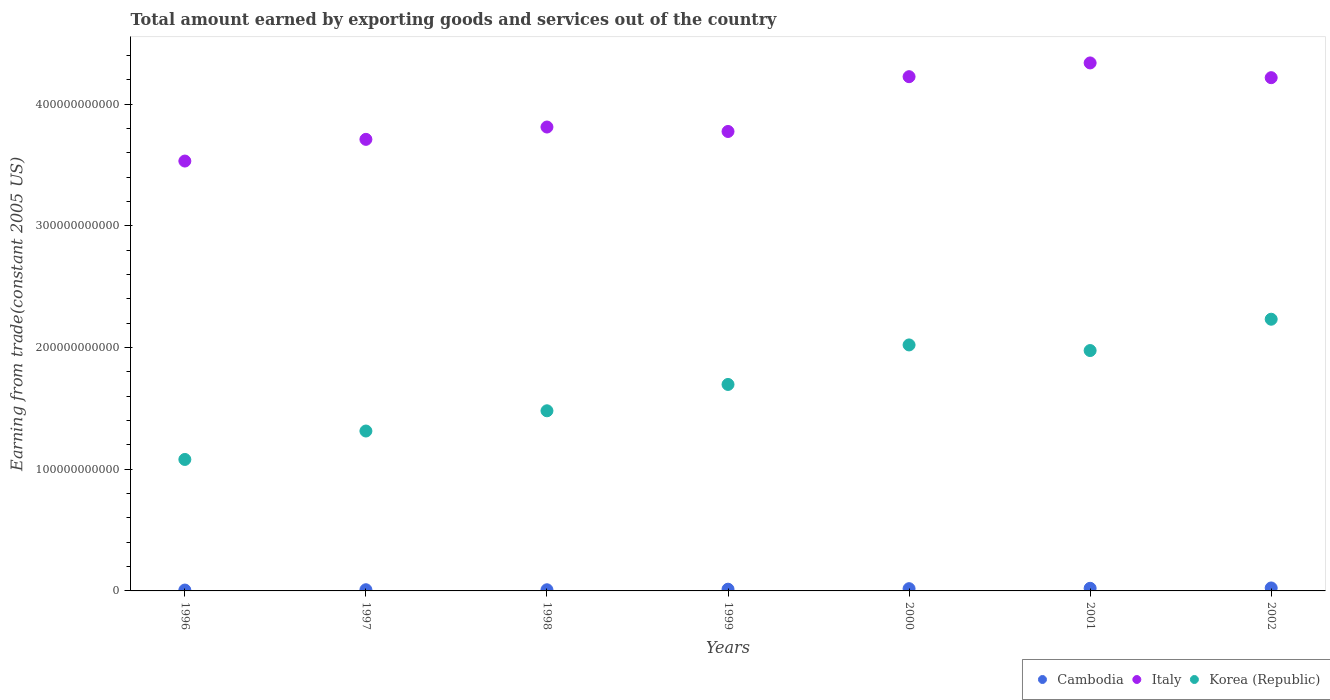Is the number of dotlines equal to the number of legend labels?
Offer a very short reply. Yes. What is the total amount earned by exporting goods and services in Cambodia in 1998?
Make the answer very short. 9.47e+08. Across all years, what is the maximum total amount earned by exporting goods and services in Italy?
Offer a terse response. 4.34e+11. Across all years, what is the minimum total amount earned by exporting goods and services in Korea (Republic)?
Offer a very short reply. 1.08e+11. What is the total total amount earned by exporting goods and services in Korea (Republic) in the graph?
Keep it short and to the point. 1.18e+12. What is the difference between the total amount earned by exporting goods and services in Italy in 1996 and that in 2002?
Your answer should be compact. -6.85e+1. What is the difference between the total amount earned by exporting goods and services in Italy in 1999 and the total amount earned by exporting goods and services in Korea (Republic) in 2001?
Provide a short and direct response. 1.80e+11. What is the average total amount earned by exporting goods and services in Italy per year?
Your answer should be very brief. 3.94e+11. In the year 1999, what is the difference between the total amount earned by exporting goods and services in Korea (Republic) and total amount earned by exporting goods and services in Italy?
Provide a short and direct response. -2.08e+11. In how many years, is the total amount earned by exporting goods and services in Cambodia greater than 280000000000 US$?
Provide a short and direct response. 0. What is the ratio of the total amount earned by exporting goods and services in Italy in 1996 to that in 2002?
Your response must be concise. 0.84. Is the total amount earned by exporting goods and services in Cambodia in 1996 less than that in 2001?
Give a very brief answer. Yes. What is the difference between the highest and the second highest total amount earned by exporting goods and services in Italy?
Keep it short and to the point. 1.13e+1. What is the difference between the highest and the lowest total amount earned by exporting goods and services in Italy?
Provide a succinct answer. 8.06e+1. In how many years, is the total amount earned by exporting goods and services in Cambodia greater than the average total amount earned by exporting goods and services in Cambodia taken over all years?
Keep it short and to the point. 3. Is the sum of the total amount earned by exporting goods and services in Italy in 1996 and 2002 greater than the maximum total amount earned by exporting goods and services in Cambodia across all years?
Your answer should be very brief. Yes. Is the total amount earned by exporting goods and services in Italy strictly greater than the total amount earned by exporting goods and services in Cambodia over the years?
Keep it short and to the point. Yes. How many years are there in the graph?
Your response must be concise. 7. What is the difference between two consecutive major ticks on the Y-axis?
Your response must be concise. 1.00e+11. Does the graph contain grids?
Provide a succinct answer. No. Where does the legend appear in the graph?
Your answer should be very brief. Bottom right. What is the title of the graph?
Your answer should be very brief. Total amount earned by exporting goods and services out of the country. What is the label or title of the Y-axis?
Your answer should be very brief. Earning from trade(constant 2005 US). What is the Earning from trade(constant 2005 US) of Cambodia in 1996?
Offer a very short reply. 7.17e+08. What is the Earning from trade(constant 2005 US) in Italy in 1996?
Keep it short and to the point. 3.53e+11. What is the Earning from trade(constant 2005 US) in Korea (Republic) in 1996?
Ensure brevity in your answer.  1.08e+11. What is the Earning from trade(constant 2005 US) of Cambodia in 1997?
Provide a short and direct response. 9.76e+08. What is the Earning from trade(constant 2005 US) in Italy in 1997?
Your answer should be very brief. 3.71e+11. What is the Earning from trade(constant 2005 US) of Korea (Republic) in 1997?
Give a very brief answer. 1.31e+11. What is the Earning from trade(constant 2005 US) in Cambodia in 1998?
Your response must be concise. 9.47e+08. What is the Earning from trade(constant 2005 US) of Italy in 1998?
Offer a very short reply. 3.81e+11. What is the Earning from trade(constant 2005 US) of Korea (Republic) in 1998?
Offer a terse response. 1.48e+11. What is the Earning from trade(constant 2005 US) in Cambodia in 1999?
Keep it short and to the point. 1.42e+09. What is the Earning from trade(constant 2005 US) in Italy in 1999?
Your response must be concise. 3.77e+11. What is the Earning from trade(constant 2005 US) in Korea (Republic) in 1999?
Ensure brevity in your answer.  1.70e+11. What is the Earning from trade(constant 2005 US) of Cambodia in 2000?
Ensure brevity in your answer.  1.85e+09. What is the Earning from trade(constant 2005 US) in Italy in 2000?
Keep it short and to the point. 4.22e+11. What is the Earning from trade(constant 2005 US) in Korea (Republic) in 2000?
Make the answer very short. 2.02e+11. What is the Earning from trade(constant 2005 US) in Cambodia in 2001?
Keep it short and to the point. 2.15e+09. What is the Earning from trade(constant 2005 US) of Italy in 2001?
Give a very brief answer. 4.34e+11. What is the Earning from trade(constant 2005 US) of Korea (Republic) in 2001?
Provide a short and direct response. 1.97e+11. What is the Earning from trade(constant 2005 US) of Cambodia in 2002?
Provide a short and direct response. 2.44e+09. What is the Earning from trade(constant 2005 US) of Italy in 2002?
Offer a very short reply. 4.22e+11. What is the Earning from trade(constant 2005 US) of Korea (Republic) in 2002?
Keep it short and to the point. 2.23e+11. Across all years, what is the maximum Earning from trade(constant 2005 US) in Cambodia?
Make the answer very short. 2.44e+09. Across all years, what is the maximum Earning from trade(constant 2005 US) of Italy?
Provide a succinct answer. 4.34e+11. Across all years, what is the maximum Earning from trade(constant 2005 US) in Korea (Republic)?
Your response must be concise. 2.23e+11. Across all years, what is the minimum Earning from trade(constant 2005 US) of Cambodia?
Keep it short and to the point. 7.17e+08. Across all years, what is the minimum Earning from trade(constant 2005 US) of Italy?
Offer a terse response. 3.53e+11. Across all years, what is the minimum Earning from trade(constant 2005 US) in Korea (Republic)?
Your response must be concise. 1.08e+11. What is the total Earning from trade(constant 2005 US) of Cambodia in the graph?
Keep it short and to the point. 1.05e+1. What is the total Earning from trade(constant 2005 US) in Italy in the graph?
Ensure brevity in your answer.  2.76e+12. What is the total Earning from trade(constant 2005 US) in Korea (Republic) in the graph?
Your response must be concise. 1.18e+12. What is the difference between the Earning from trade(constant 2005 US) of Cambodia in 1996 and that in 1997?
Give a very brief answer. -2.59e+08. What is the difference between the Earning from trade(constant 2005 US) in Italy in 1996 and that in 1997?
Your response must be concise. -1.78e+1. What is the difference between the Earning from trade(constant 2005 US) of Korea (Republic) in 1996 and that in 1997?
Provide a succinct answer. -2.34e+1. What is the difference between the Earning from trade(constant 2005 US) of Cambodia in 1996 and that in 1998?
Give a very brief answer. -2.30e+08. What is the difference between the Earning from trade(constant 2005 US) of Italy in 1996 and that in 1998?
Offer a terse response. -2.79e+1. What is the difference between the Earning from trade(constant 2005 US) in Korea (Republic) in 1996 and that in 1998?
Offer a terse response. -4.00e+1. What is the difference between the Earning from trade(constant 2005 US) in Cambodia in 1996 and that in 1999?
Provide a short and direct response. -7.00e+08. What is the difference between the Earning from trade(constant 2005 US) of Italy in 1996 and that in 1999?
Offer a terse response. -2.43e+1. What is the difference between the Earning from trade(constant 2005 US) of Korea (Republic) in 1996 and that in 1999?
Keep it short and to the point. -6.16e+1. What is the difference between the Earning from trade(constant 2005 US) of Cambodia in 1996 and that in 2000?
Give a very brief answer. -1.13e+09. What is the difference between the Earning from trade(constant 2005 US) in Italy in 1996 and that in 2000?
Offer a terse response. -6.93e+1. What is the difference between the Earning from trade(constant 2005 US) in Korea (Republic) in 1996 and that in 2000?
Keep it short and to the point. -9.41e+1. What is the difference between the Earning from trade(constant 2005 US) in Cambodia in 1996 and that in 2001?
Offer a terse response. -1.44e+09. What is the difference between the Earning from trade(constant 2005 US) in Italy in 1996 and that in 2001?
Give a very brief answer. -8.06e+1. What is the difference between the Earning from trade(constant 2005 US) of Korea (Republic) in 1996 and that in 2001?
Ensure brevity in your answer.  -8.95e+1. What is the difference between the Earning from trade(constant 2005 US) of Cambodia in 1996 and that in 2002?
Your response must be concise. -1.72e+09. What is the difference between the Earning from trade(constant 2005 US) of Italy in 1996 and that in 2002?
Ensure brevity in your answer.  -6.85e+1. What is the difference between the Earning from trade(constant 2005 US) of Korea (Republic) in 1996 and that in 2002?
Keep it short and to the point. -1.15e+11. What is the difference between the Earning from trade(constant 2005 US) in Cambodia in 1997 and that in 1998?
Keep it short and to the point. 2.89e+07. What is the difference between the Earning from trade(constant 2005 US) of Italy in 1997 and that in 1998?
Your answer should be compact. -1.01e+1. What is the difference between the Earning from trade(constant 2005 US) in Korea (Republic) in 1997 and that in 1998?
Offer a terse response. -1.66e+1. What is the difference between the Earning from trade(constant 2005 US) in Cambodia in 1997 and that in 1999?
Make the answer very short. -4.41e+08. What is the difference between the Earning from trade(constant 2005 US) of Italy in 1997 and that in 1999?
Ensure brevity in your answer.  -6.47e+09. What is the difference between the Earning from trade(constant 2005 US) of Korea (Republic) in 1997 and that in 1999?
Offer a terse response. -3.83e+1. What is the difference between the Earning from trade(constant 2005 US) of Cambodia in 1997 and that in 2000?
Your answer should be very brief. -8.70e+08. What is the difference between the Earning from trade(constant 2005 US) in Italy in 1997 and that in 2000?
Your answer should be compact. -5.15e+1. What is the difference between the Earning from trade(constant 2005 US) of Korea (Republic) in 1997 and that in 2000?
Your answer should be compact. -7.07e+1. What is the difference between the Earning from trade(constant 2005 US) in Cambodia in 1997 and that in 2001?
Ensure brevity in your answer.  -1.18e+09. What is the difference between the Earning from trade(constant 2005 US) of Italy in 1997 and that in 2001?
Offer a terse response. -6.28e+1. What is the difference between the Earning from trade(constant 2005 US) of Korea (Republic) in 1997 and that in 2001?
Offer a very short reply. -6.61e+1. What is the difference between the Earning from trade(constant 2005 US) of Cambodia in 1997 and that in 2002?
Offer a very short reply. -1.46e+09. What is the difference between the Earning from trade(constant 2005 US) of Italy in 1997 and that in 2002?
Offer a very short reply. -5.07e+1. What is the difference between the Earning from trade(constant 2005 US) of Korea (Republic) in 1997 and that in 2002?
Provide a short and direct response. -9.18e+1. What is the difference between the Earning from trade(constant 2005 US) of Cambodia in 1998 and that in 1999?
Offer a terse response. -4.70e+08. What is the difference between the Earning from trade(constant 2005 US) in Italy in 1998 and that in 1999?
Offer a terse response. 3.66e+09. What is the difference between the Earning from trade(constant 2005 US) of Korea (Republic) in 1998 and that in 1999?
Make the answer very short. -2.16e+1. What is the difference between the Earning from trade(constant 2005 US) of Cambodia in 1998 and that in 2000?
Provide a succinct answer. -8.99e+08. What is the difference between the Earning from trade(constant 2005 US) in Italy in 1998 and that in 2000?
Ensure brevity in your answer.  -4.14e+1. What is the difference between the Earning from trade(constant 2005 US) of Korea (Republic) in 1998 and that in 2000?
Your answer should be very brief. -5.41e+1. What is the difference between the Earning from trade(constant 2005 US) of Cambodia in 1998 and that in 2001?
Make the answer very short. -1.21e+09. What is the difference between the Earning from trade(constant 2005 US) of Italy in 1998 and that in 2001?
Make the answer very short. -5.27e+1. What is the difference between the Earning from trade(constant 2005 US) in Korea (Republic) in 1998 and that in 2001?
Ensure brevity in your answer.  -4.95e+1. What is the difference between the Earning from trade(constant 2005 US) in Cambodia in 1998 and that in 2002?
Ensure brevity in your answer.  -1.49e+09. What is the difference between the Earning from trade(constant 2005 US) in Italy in 1998 and that in 2002?
Give a very brief answer. -4.05e+1. What is the difference between the Earning from trade(constant 2005 US) of Korea (Republic) in 1998 and that in 2002?
Keep it short and to the point. -7.52e+1. What is the difference between the Earning from trade(constant 2005 US) in Cambodia in 1999 and that in 2000?
Your response must be concise. -4.29e+08. What is the difference between the Earning from trade(constant 2005 US) in Italy in 1999 and that in 2000?
Your answer should be very brief. -4.50e+1. What is the difference between the Earning from trade(constant 2005 US) in Korea (Republic) in 1999 and that in 2000?
Your answer should be very brief. -3.25e+1. What is the difference between the Earning from trade(constant 2005 US) in Cambodia in 1999 and that in 2001?
Give a very brief answer. -7.37e+08. What is the difference between the Earning from trade(constant 2005 US) in Italy in 1999 and that in 2001?
Your response must be concise. -5.63e+1. What is the difference between the Earning from trade(constant 2005 US) in Korea (Republic) in 1999 and that in 2001?
Provide a short and direct response. -2.79e+1. What is the difference between the Earning from trade(constant 2005 US) of Cambodia in 1999 and that in 2002?
Your answer should be very brief. -1.02e+09. What is the difference between the Earning from trade(constant 2005 US) in Italy in 1999 and that in 2002?
Offer a very short reply. -4.42e+1. What is the difference between the Earning from trade(constant 2005 US) of Korea (Republic) in 1999 and that in 2002?
Ensure brevity in your answer.  -5.36e+1. What is the difference between the Earning from trade(constant 2005 US) of Cambodia in 2000 and that in 2001?
Make the answer very short. -3.08e+08. What is the difference between the Earning from trade(constant 2005 US) in Italy in 2000 and that in 2001?
Provide a succinct answer. -1.13e+1. What is the difference between the Earning from trade(constant 2005 US) in Korea (Republic) in 2000 and that in 2001?
Your answer should be very brief. 4.62e+09. What is the difference between the Earning from trade(constant 2005 US) in Cambodia in 2000 and that in 2002?
Make the answer very short. -5.89e+08. What is the difference between the Earning from trade(constant 2005 US) of Italy in 2000 and that in 2002?
Offer a terse response. 8.18e+08. What is the difference between the Earning from trade(constant 2005 US) in Korea (Republic) in 2000 and that in 2002?
Your answer should be very brief. -2.11e+1. What is the difference between the Earning from trade(constant 2005 US) of Cambodia in 2001 and that in 2002?
Provide a short and direct response. -2.81e+08. What is the difference between the Earning from trade(constant 2005 US) in Italy in 2001 and that in 2002?
Provide a short and direct response. 1.21e+1. What is the difference between the Earning from trade(constant 2005 US) in Korea (Republic) in 2001 and that in 2002?
Offer a terse response. -2.57e+1. What is the difference between the Earning from trade(constant 2005 US) of Cambodia in 1996 and the Earning from trade(constant 2005 US) of Italy in 1997?
Give a very brief answer. -3.70e+11. What is the difference between the Earning from trade(constant 2005 US) in Cambodia in 1996 and the Earning from trade(constant 2005 US) in Korea (Republic) in 1997?
Your answer should be compact. -1.31e+11. What is the difference between the Earning from trade(constant 2005 US) in Italy in 1996 and the Earning from trade(constant 2005 US) in Korea (Republic) in 1997?
Your answer should be compact. 2.22e+11. What is the difference between the Earning from trade(constant 2005 US) of Cambodia in 1996 and the Earning from trade(constant 2005 US) of Italy in 1998?
Offer a terse response. -3.80e+11. What is the difference between the Earning from trade(constant 2005 US) in Cambodia in 1996 and the Earning from trade(constant 2005 US) in Korea (Republic) in 1998?
Your answer should be compact. -1.47e+11. What is the difference between the Earning from trade(constant 2005 US) in Italy in 1996 and the Earning from trade(constant 2005 US) in Korea (Republic) in 1998?
Ensure brevity in your answer.  2.05e+11. What is the difference between the Earning from trade(constant 2005 US) in Cambodia in 1996 and the Earning from trade(constant 2005 US) in Italy in 1999?
Keep it short and to the point. -3.77e+11. What is the difference between the Earning from trade(constant 2005 US) in Cambodia in 1996 and the Earning from trade(constant 2005 US) in Korea (Republic) in 1999?
Your answer should be very brief. -1.69e+11. What is the difference between the Earning from trade(constant 2005 US) of Italy in 1996 and the Earning from trade(constant 2005 US) of Korea (Republic) in 1999?
Your response must be concise. 1.84e+11. What is the difference between the Earning from trade(constant 2005 US) of Cambodia in 1996 and the Earning from trade(constant 2005 US) of Italy in 2000?
Keep it short and to the point. -4.22e+11. What is the difference between the Earning from trade(constant 2005 US) in Cambodia in 1996 and the Earning from trade(constant 2005 US) in Korea (Republic) in 2000?
Give a very brief answer. -2.01e+11. What is the difference between the Earning from trade(constant 2005 US) in Italy in 1996 and the Earning from trade(constant 2005 US) in Korea (Republic) in 2000?
Offer a very short reply. 1.51e+11. What is the difference between the Earning from trade(constant 2005 US) in Cambodia in 1996 and the Earning from trade(constant 2005 US) in Italy in 2001?
Offer a terse response. -4.33e+11. What is the difference between the Earning from trade(constant 2005 US) of Cambodia in 1996 and the Earning from trade(constant 2005 US) of Korea (Republic) in 2001?
Make the answer very short. -1.97e+11. What is the difference between the Earning from trade(constant 2005 US) of Italy in 1996 and the Earning from trade(constant 2005 US) of Korea (Republic) in 2001?
Make the answer very short. 1.56e+11. What is the difference between the Earning from trade(constant 2005 US) in Cambodia in 1996 and the Earning from trade(constant 2005 US) in Italy in 2002?
Keep it short and to the point. -4.21e+11. What is the difference between the Earning from trade(constant 2005 US) of Cambodia in 1996 and the Earning from trade(constant 2005 US) of Korea (Republic) in 2002?
Your answer should be very brief. -2.22e+11. What is the difference between the Earning from trade(constant 2005 US) of Italy in 1996 and the Earning from trade(constant 2005 US) of Korea (Republic) in 2002?
Your response must be concise. 1.30e+11. What is the difference between the Earning from trade(constant 2005 US) in Cambodia in 1997 and the Earning from trade(constant 2005 US) in Italy in 1998?
Provide a succinct answer. -3.80e+11. What is the difference between the Earning from trade(constant 2005 US) of Cambodia in 1997 and the Earning from trade(constant 2005 US) of Korea (Republic) in 1998?
Provide a succinct answer. -1.47e+11. What is the difference between the Earning from trade(constant 2005 US) in Italy in 1997 and the Earning from trade(constant 2005 US) in Korea (Republic) in 1998?
Your response must be concise. 2.23e+11. What is the difference between the Earning from trade(constant 2005 US) in Cambodia in 1997 and the Earning from trade(constant 2005 US) in Italy in 1999?
Your answer should be very brief. -3.76e+11. What is the difference between the Earning from trade(constant 2005 US) in Cambodia in 1997 and the Earning from trade(constant 2005 US) in Korea (Republic) in 1999?
Provide a succinct answer. -1.69e+11. What is the difference between the Earning from trade(constant 2005 US) of Italy in 1997 and the Earning from trade(constant 2005 US) of Korea (Republic) in 1999?
Provide a short and direct response. 2.01e+11. What is the difference between the Earning from trade(constant 2005 US) in Cambodia in 1997 and the Earning from trade(constant 2005 US) in Italy in 2000?
Your answer should be very brief. -4.21e+11. What is the difference between the Earning from trade(constant 2005 US) of Cambodia in 1997 and the Earning from trade(constant 2005 US) of Korea (Republic) in 2000?
Give a very brief answer. -2.01e+11. What is the difference between the Earning from trade(constant 2005 US) of Italy in 1997 and the Earning from trade(constant 2005 US) of Korea (Republic) in 2000?
Provide a succinct answer. 1.69e+11. What is the difference between the Earning from trade(constant 2005 US) of Cambodia in 1997 and the Earning from trade(constant 2005 US) of Italy in 2001?
Ensure brevity in your answer.  -4.33e+11. What is the difference between the Earning from trade(constant 2005 US) of Cambodia in 1997 and the Earning from trade(constant 2005 US) of Korea (Republic) in 2001?
Provide a short and direct response. -1.96e+11. What is the difference between the Earning from trade(constant 2005 US) of Italy in 1997 and the Earning from trade(constant 2005 US) of Korea (Republic) in 2001?
Make the answer very short. 1.73e+11. What is the difference between the Earning from trade(constant 2005 US) in Cambodia in 1997 and the Earning from trade(constant 2005 US) in Italy in 2002?
Offer a very short reply. -4.21e+11. What is the difference between the Earning from trade(constant 2005 US) in Cambodia in 1997 and the Earning from trade(constant 2005 US) in Korea (Republic) in 2002?
Your answer should be very brief. -2.22e+11. What is the difference between the Earning from trade(constant 2005 US) in Italy in 1997 and the Earning from trade(constant 2005 US) in Korea (Republic) in 2002?
Your answer should be very brief. 1.48e+11. What is the difference between the Earning from trade(constant 2005 US) of Cambodia in 1998 and the Earning from trade(constant 2005 US) of Italy in 1999?
Give a very brief answer. -3.76e+11. What is the difference between the Earning from trade(constant 2005 US) of Cambodia in 1998 and the Earning from trade(constant 2005 US) of Korea (Republic) in 1999?
Your response must be concise. -1.69e+11. What is the difference between the Earning from trade(constant 2005 US) in Italy in 1998 and the Earning from trade(constant 2005 US) in Korea (Republic) in 1999?
Offer a very short reply. 2.11e+11. What is the difference between the Earning from trade(constant 2005 US) in Cambodia in 1998 and the Earning from trade(constant 2005 US) in Italy in 2000?
Offer a terse response. -4.22e+11. What is the difference between the Earning from trade(constant 2005 US) in Cambodia in 1998 and the Earning from trade(constant 2005 US) in Korea (Republic) in 2000?
Your answer should be very brief. -2.01e+11. What is the difference between the Earning from trade(constant 2005 US) in Italy in 1998 and the Earning from trade(constant 2005 US) in Korea (Republic) in 2000?
Provide a succinct answer. 1.79e+11. What is the difference between the Earning from trade(constant 2005 US) in Cambodia in 1998 and the Earning from trade(constant 2005 US) in Italy in 2001?
Provide a succinct answer. -4.33e+11. What is the difference between the Earning from trade(constant 2005 US) in Cambodia in 1998 and the Earning from trade(constant 2005 US) in Korea (Republic) in 2001?
Keep it short and to the point. -1.97e+11. What is the difference between the Earning from trade(constant 2005 US) of Italy in 1998 and the Earning from trade(constant 2005 US) of Korea (Republic) in 2001?
Provide a short and direct response. 1.84e+11. What is the difference between the Earning from trade(constant 2005 US) in Cambodia in 1998 and the Earning from trade(constant 2005 US) in Italy in 2002?
Offer a very short reply. -4.21e+11. What is the difference between the Earning from trade(constant 2005 US) in Cambodia in 1998 and the Earning from trade(constant 2005 US) in Korea (Republic) in 2002?
Offer a terse response. -2.22e+11. What is the difference between the Earning from trade(constant 2005 US) in Italy in 1998 and the Earning from trade(constant 2005 US) in Korea (Republic) in 2002?
Offer a very short reply. 1.58e+11. What is the difference between the Earning from trade(constant 2005 US) in Cambodia in 1999 and the Earning from trade(constant 2005 US) in Italy in 2000?
Make the answer very short. -4.21e+11. What is the difference between the Earning from trade(constant 2005 US) in Cambodia in 1999 and the Earning from trade(constant 2005 US) in Korea (Republic) in 2000?
Offer a terse response. -2.01e+11. What is the difference between the Earning from trade(constant 2005 US) in Italy in 1999 and the Earning from trade(constant 2005 US) in Korea (Republic) in 2000?
Provide a succinct answer. 1.75e+11. What is the difference between the Earning from trade(constant 2005 US) in Cambodia in 1999 and the Earning from trade(constant 2005 US) in Italy in 2001?
Offer a terse response. -4.32e+11. What is the difference between the Earning from trade(constant 2005 US) of Cambodia in 1999 and the Earning from trade(constant 2005 US) of Korea (Republic) in 2001?
Offer a very short reply. -1.96e+11. What is the difference between the Earning from trade(constant 2005 US) in Italy in 1999 and the Earning from trade(constant 2005 US) in Korea (Republic) in 2001?
Make the answer very short. 1.80e+11. What is the difference between the Earning from trade(constant 2005 US) of Cambodia in 1999 and the Earning from trade(constant 2005 US) of Italy in 2002?
Provide a short and direct response. -4.20e+11. What is the difference between the Earning from trade(constant 2005 US) in Cambodia in 1999 and the Earning from trade(constant 2005 US) in Korea (Republic) in 2002?
Your response must be concise. -2.22e+11. What is the difference between the Earning from trade(constant 2005 US) in Italy in 1999 and the Earning from trade(constant 2005 US) in Korea (Republic) in 2002?
Provide a succinct answer. 1.54e+11. What is the difference between the Earning from trade(constant 2005 US) in Cambodia in 2000 and the Earning from trade(constant 2005 US) in Italy in 2001?
Provide a short and direct response. -4.32e+11. What is the difference between the Earning from trade(constant 2005 US) in Cambodia in 2000 and the Earning from trade(constant 2005 US) in Korea (Republic) in 2001?
Your answer should be very brief. -1.96e+11. What is the difference between the Earning from trade(constant 2005 US) in Italy in 2000 and the Earning from trade(constant 2005 US) in Korea (Republic) in 2001?
Make the answer very short. 2.25e+11. What is the difference between the Earning from trade(constant 2005 US) in Cambodia in 2000 and the Earning from trade(constant 2005 US) in Italy in 2002?
Ensure brevity in your answer.  -4.20e+11. What is the difference between the Earning from trade(constant 2005 US) of Cambodia in 2000 and the Earning from trade(constant 2005 US) of Korea (Republic) in 2002?
Your answer should be compact. -2.21e+11. What is the difference between the Earning from trade(constant 2005 US) in Italy in 2000 and the Earning from trade(constant 2005 US) in Korea (Republic) in 2002?
Your response must be concise. 1.99e+11. What is the difference between the Earning from trade(constant 2005 US) in Cambodia in 2001 and the Earning from trade(constant 2005 US) in Italy in 2002?
Your response must be concise. -4.19e+11. What is the difference between the Earning from trade(constant 2005 US) in Cambodia in 2001 and the Earning from trade(constant 2005 US) in Korea (Republic) in 2002?
Provide a succinct answer. -2.21e+11. What is the difference between the Earning from trade(constant 2005 US) in Italy in 2001 and the Earning from trade(constant 2005 US) in Korea (Republic) in 2002?
Provide a succinct answer. 2.11e+11. What is the average Earning from trade(constant 2005 US) in Cambodia per year?
Offer a terse response. 1.50e+09. What is the average Earning from trade(constant 2005 US) in Italy per year?
Make the answer very short. 3.94e+11. What is the average Earning from trade(constant 2005 US) of Korea (Republic) per year?
Ensure brevity in your answer.  1.69e+11. In the year 1996, what is the difference between the Earning from trade(constant 2005 US) in Cambodia and Earning from trade(constant 2005 US) in Italy?
Provide a short and direct response. -3.52e+11. In the year 1996, what is the difference between the Earning from trade(constant 2005 US) in Cambodia and Earning from trade(constant 2005 US) in Korea (Republic)?
Provide a succinct answer. -1.07e+11. In the year 1996, what is the difference between the Earning from trade(constant 2005 US) of Italy and Earning from trade(constant 2005 US) of Korea (Republic)?
Your response must be concise. 2.45e+11. In the year 1997, what is the difference between the Earning from trade(constant 2005 US) of Cambodia and Earning from trade(constant 2005 US) of Italy?
Provide a short and direct response. -3.70e+11. In the year 1997, what is the difference between the Earning from trade(constant 2005 US) of Cambodia and Earning from trade(constant 2005 US) of Korea (Republic)?
Provide a short and direct response. -1.30e+11. In the year 1997, what is the difference between the Earning from trade(constant 2005 US) in Italy and Earning from trade(constant 2005 US) in Korea (Republic)?
Your answer should be very brief. 2.40e+11. In the year 1998, what is the difference between the Earning from trade(constant 2005 US) in Cambodia and Earning from trade(constant 2005 US) in Italy?
Your response must be concise. -3.80e+11. In the year 1998, what is the difference between the Earning from trade(constant 2005 US) of Cambodia and Earning from trade(constant 2005 US) of Korea (Republic)?
Keep it short and to the point. -1.47e+11. In the year 1998, what is the difference between the Earning from trade(constant 2005 US) in Italy and Earning from trade(constant 2005 US) in Korea (Republic)?
Your answer should be very brief. 2.33e+11. In the year 1999, what is the difference between the Earning from trade(constant 2005 US) in Cambodia and Earning from trade(constant 2005 US) in Italy?
Provide a succinct answer. -3.76e+11. In the year 1999, what is the difference between the Earning from trade(constant 2005 US) of Cambodia and Earning from trade(constant 2005 US) of Korea (Republic)?
Your answer should be compact. -1.68e+11. In the year 1999, what is the difference between the Earning from trade(constant 2005 US) in Italy and Earning from trade(constant 2005 US) in Korea (Republic)?
Offer a terse response. 2.08e+11. In the year 2000, what is the difference between the Earning from trade(constant 2005 US) in Cambodia and Earning from trade(constant 2005 US) in Italy?
Provide a succinct answer. -4.21e+11. In the year 2000, what is the difference between the Earning from trade(constant 2005 US) of Cambodia and Earning from trade(constant 2005 US) of Korea (Republic)?
Give a very brief answer. -2.00e+11. In the year 2000, what is the difference between the Earning from trade(constant 2005 US) in Italy and Earning from trade(constant 2005 US) in Korea (Republic)?
Your answer should be very brief. 2.20e+11. In the year 2001, what is the difference between the Earning from trade(constant 2005 US) in Cambodia and Earning from trade(constant 2005 US) in Italy?
Keep it short and to the point. -4.32e+11. In the year 2001, what is the difference between the Earning from trade(constant 2005 US) of Cambodia and Earning from trade(constant 2005 US) of Korea (Republic)?
Provide a succinct answer. -1.95e+11. In the year 2001, what is the difference between the Earning from trade(constant 2005 US) of Italy and Earning from trade(constant 2005 US) of Korea (Republic)?
Ensure brevity in your answer.  2.36e+11. In the year 2002, what is the difference between the Earning from trade(constant 2005 US) in Cambodia and Earning from trade(constant 2005 US) in Italy?
Give a very brief answer. -4.19e+11. In the year 2002, what is the difference between the Earning from trade(constant 2005 US) in Cambodia and Earning from trade(constant 2005 US) in Korea (Republic)?
Give a very brief answer. -2.21e+11. In the year 2002, what is the difference between the Earning from trade(constant 2005 US) of Italy and Earning from trade(constant 2005 US) of Korea (Republic)?
Offer a very short reply. 1.98e+11. What is the ratio of the Earning from trade(constant 2005 US) in Cambodia in 1996 to that in 1997?
Offer a terse response. 0.73. What is the ratio of the Earning from trade(constant 2005 US) in Italy in 1996 to that in 1997?
Provide a succinct answer. 0.95. What is the ratio of the Earning from trade(constant 2005 US) in Korea (Republic) in 1996 to that in 1997?
Ensure brevity in your answer.  0.82. What is the ratio of the Earning from trade(constant 2005 US) of Cambodia in 1996 to that in 1998?
Offer a very short reply. 0.76. What is the ratio of the Earning from trade(constant 2005 US) of Italy in 1996 to that in 1998?
Your answer should be very brief. 0.93. What is the ratio of the Earning from trade(constant 2005 US) in Korea (Republic) in 1996 to that in 1998?
Your response must be concise. 0.73. What is the ratio of the Earning from trade(constant 2005 US) in Cambodia in 1996 to that in 1999?
Your answer should be very brief. 0.51. What is the ratio of the Earning from trade(constant 2005 US) in Italy in 1996 to that in 1999?
Your answer should be very brief. 0.94. What is the ratio of the Earning from trade(constant 2005 US) in Korea (Republic) in 1996 to that in 1999?
Make the answer very short. 0.64. What is the ratio of the Earning from trade(constant 2005 US) of Cambodia in 1996 to that in 2000?
Your response must be concise. 0.39. What is the ratio of the Earning from trade(constant 2005 US) in Italy in 1996 to that in 2000?
Provide a short and direct response. 0.84. What is the ratio of the Earning from trade(constant 2005 US) of Korea (Republic) in 1996 to that in 2000?
Your answer should be very brief. 0.53. What is the ratio of the Earning from trade(constant 2005 US) of Cambodia in 1996 to that in 2001?
Provide a short and direct response. 0.33. What is the ratio of the Earning from trade(constant 2005 US) of Italy in 1996 to that in 2001?
Keep it short and to the point. 0.81. What is the ratio of the Earning from trade(constant 2005 US) in Korea (Republic) in 1996 to that in 2001?
Keep it short and to the point. 0.55. What is the ratio of the Earning from trade(constant 2005 US) in Cambodia in 1996 to that in 2002?
Give a very brief answer. 0.29. What is the ratio of the Earning from trade(constant 2005 US) in Italy in 1996 to that in 2002?
Ensure brevity in your answer.  0.84. What is the ratio of the Earning from trade(constant 2005 US) of Korea (Republic) in 1996 to that in 2002?
Your answer should be very brief. 0.48. What is the ratio of the Earning from trade(constant 2005 US) in Cambodia in 1997 to that in 1998?
Your answer should be very brief. 1.03. What is the ratio of the Earning from trade(constant 2005 US) in Italy in 1997 to that in 1998?
Your response must be concise. 0.97. What is the ratio of the Earning from trade(constant 2005 US) in Korea (Republic) in 1997 to that in 1998?
Keep it short and to the point. 0.89. What is the ratio of the Earning from trade(constant 2005 US) in Cambodia in 1997 to that in 1999?
Keep it short and to the point. 0.69. What is the ratio of the Earning from trade(constant 2005 US) of Italy in 1997 to that in 1999?
Your response must be concise. 0.98. What is the ratio of the Earning from trade(constant 2005 US) of Korea (Republic) in 1997 to that in 1999?
Make the answer very short. 0.77. What is the ratio of the Earning from trade(constant 2005 US) of Cambodia in 1997 to that in 2000?
Ensure brevity in your answer.  0.53. What is the ratio of the Earning from trade(constant 2005 US) in Italy in 1997 to that in 2000?
Keep it short and to the point. 0.88. What is the ratio of the Earning from trade(constant 2005 US) in Korea (Republic) in 1997 to that in 2000?
Make the answer very short. 0.65. What is the ratio of the Earning from trade(constant 2005 US) in Cambodia in 1997 to that in 2001?
Provide a succinct answer. 0.45. What is the ratio of the Earning from trade(constant 2005 US) in Italy in 1997 to that in 2001?
Provide a short and direct response. 0.86. What is the ratio of the Earning from trade(constant 2005 US) in Korea (Republic) in 1997 to that in 2001?
Give a very brief answer. 0.67. What is the ratio of the Earning from trade(constant 2005 US) in Cambodia in 1997 to that in 2002?
Offer a very short reply. 0.4. What is the ratio of the Earning from trade(constant 2005 US) in Italy in 1997 to that in 2002?
Your response must be concise. 0.88. What is the ratio of the Earning from trade(constant 2005 US) in Korea (Republic) in 1997 to that in 2002?
Ensure brevity in your answer.  0.59. What is the ratio of the Earning from trade(constant 2005 US) of Cambodia in 1998 to that in 1999?
Ensure brevity in your answer.  0.67. What is the ratio of the Earning from trade(constant 2005 US) in Italy in 1998 to that in 1999?
Make the answer very short. 1.01. What is the ratio of the Earning from trade(constant 2005 US) of Korea (Republic) in 1998 to that in 1999?
Make the answer very short. 0.87. What is the ratio of the Earning from trade(constant 2005 US) of Cambodia in 1998 to that in 2000?
Give a very brief answer. 0.51. What is the ratio of the Earning from trade(constant 2005 US) in Italy in 1998 to that in 2000?
Ensure brevity in your answer.  0.9. What is the ratio of the Earning from trade(constant 2005 US) of Korea (Republic) in 1998 to that in 2000?
Provide a succinct answer. 0.73. What is the ratio of the Earning from trade(constant 2005 US) in Cambodia in 1998 to that in 2001?
Your answer should be compact. 0.44. What is the ratio of the Earning from trade(constant 2005 US) in Italy in 1998 to that in 2001?
Your answer should be very brief. 0.88. What is the ratio of the Earning from trade(constant 2005 US) in Korea (Republic) in 1998 to that in 2001?
Provide a succinct answer. 0.75. What is the ratio of the Earning from trade(constant 2005 US) of Cambodia in 1998 to that in 2002?
Your answer should be compact. 0.39. What is the ratio of the Earning from trade(constant 2005 US) in Italy in 1998 to that in 2002?
Your answer should be very brief. 0.9. What is the ratio of the Earning from trade(constant 2005 US) of Korea (Republic) in 1998 to that in 2002?
Keep it short and to the point. 0.66. What is the ratio of the Earning from trade(constant 2005 US) of Cambodia in 1999 to that in 2000?
Your answer should be very brief. 0.77. What is the ratio of the Earning from trade(constant 2005 US) of Italy in 1999 to that in 2000?
Offer a very short reply. 0.89. What is the ratio of the Earning from trade(constant 2005 US) of Korea (Republic) in 1999 to that in 2000?
Your answer should be compact. 0.84. What is the ratio of the Earning from trade(constant 2005 US) in Cambodia in 1999 to that in 2001?
Keep it short and to the point. 0.66. What is the ratio of the Earning from trade(constant 2005 US) of Italy in 1999 to that in 2001?
Keep it short and to the point. 0.87. What is the ratio of the Earning from trade(constant 2005 US) of Korea (Republic) in 1999 to that in 2001?
Your answer should be compact. 0.86. What is the ratio of the Earning from trade(constant 2005 US) of Cambodia in 1999 to that in 2002?
Make the answer very short. 0.58. What is the ratio of the Earning from trade(constant 2005 US) of Italy in 1999 to that in 2002?
Keep it short and to the point. 0.9. What is the ratio of the Earning from trade(constant 2005 US) in Korea (Republic) in 1999 to that in 2002?
Your response must be concise. 0.76. What is the ratio of the Earning from trade(constant 2005 US) of Cambodia in 2000 to that in 2001?
Make the answer very short. 0.86. What is the ratio of the Earning from trade(constant 2005 US) in Italy in 2000 to that in 2001?
Your answer should be very brief. 0.97. What is the ratio of the Earning from trade(constant 2005 US) of Korea (Republic) in 2000 to that in 2001?
Provide a short and direct response. 1.02. What is the ratio of the Earning from trade(constant 2005 US) in Cambodia in 2000 to that in 2002?
Provide a short and direct response. 0.76. What is the ratio of the Earning from trade(constant 2005 US) of Italy in 2000 to that in 2002?
Provide a succinct answer. 1. What is the ratio of the Earning from trade(constant 2005 US) of Korea (Republic) in 2000 to that in 2002?
Your response must be concise. 0.91. What is the ratio of the Earning from trade(constant 2005 US) in Cambodia in 2001 to that in 2002?
Make the answer very short. 0.88. What is the ratio of the Earning from trade(constant 2005 US) in Italy in 2001 to that in 2002?
Make the answer very short. 1.03. What is the ratio of the Earning from trade(constant 2005 US) of Korea (Republic) in 2001 to that in 2002?
Your answer should be compact. 0.88. What is the difference between the highest and the second highest Earning from trade(constant 2005 US) of Cambodia?
Ensure brevity in your answer.  2.81e+08. What is the difference between the highest and the second highest Earning from trade(constant 2005 US) in Italy?
Offer a terse response. 1.13e+1. What is the difference between the highest and the second highest Earning from trade(constant 2005 US) in Korea (Republic)?
Ensure brevity in your answer.  2.11e+1. What is the difference between the highest and the lowest Earning from trade(constant 2005 US) in Cambodia?
Offer a terse response. 1.72e+09. What is the difference between the highest and the lowest Earning from trade(constant 2005 US) in Italy?
Provide a short and direct response. 8.06e+1. What is the difference between the highest and the lowest Earning from trade(constant 2005 US) of Korea (Republic)?
Offer a very short reply. 1.15e+11. 